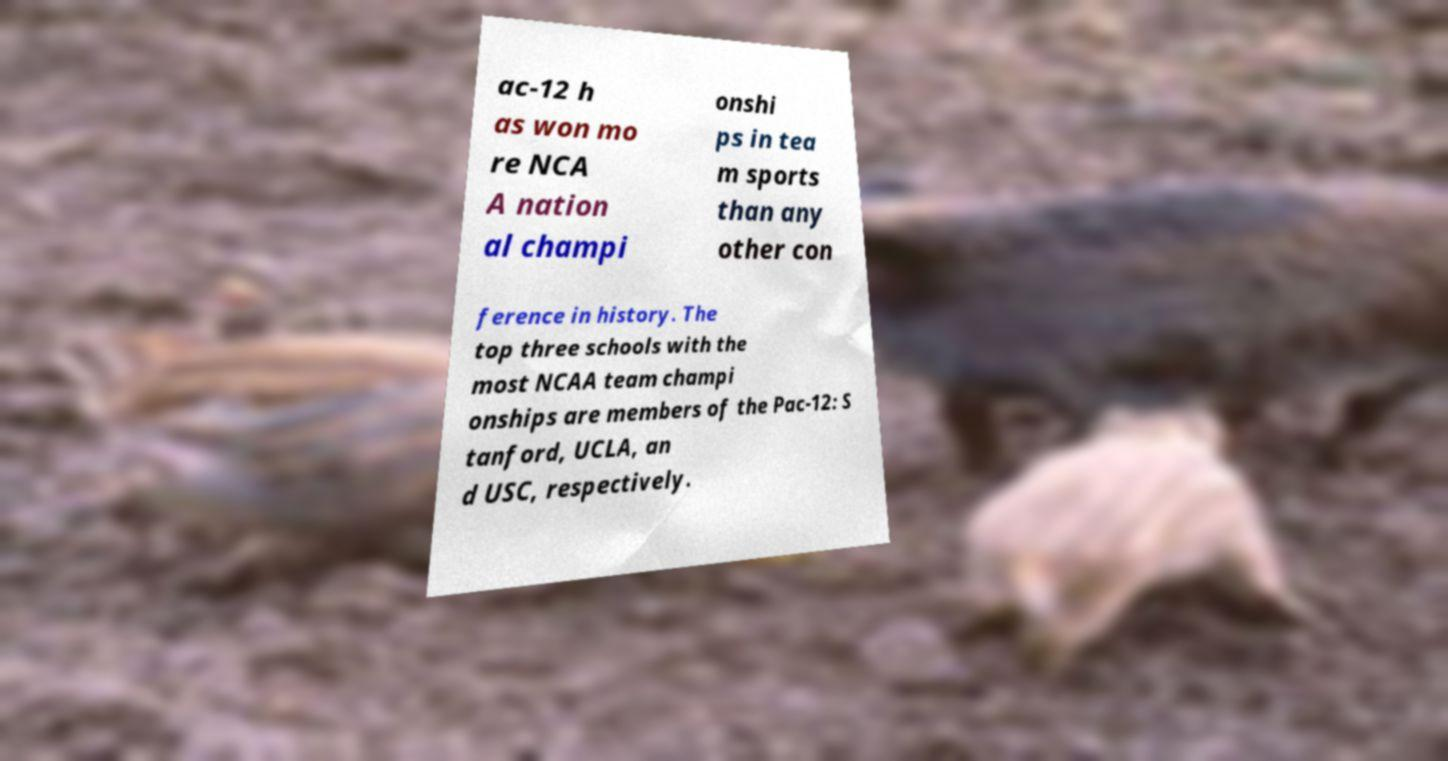Can you accurately transcribe the text from the provided image for me? ac-12 h as won mo re NCA A nation al champi onshi ps in tea m sports than any other con ference in history. The top three schools with the most NCAA team champi onships are members of the Pac-12: S tanford, UCLA, an d USC, respectively. 